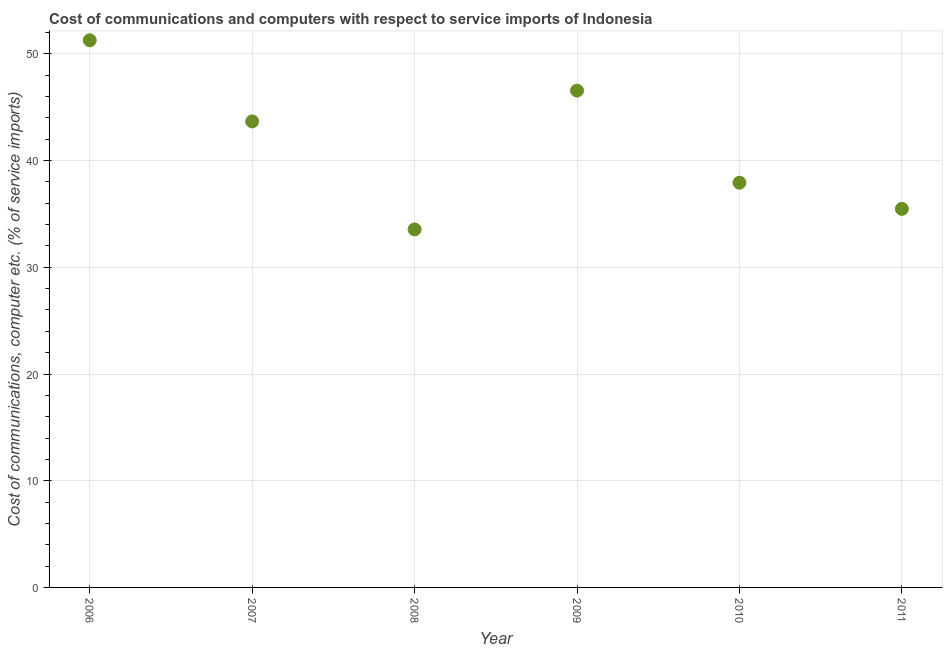What is the cost of communications and computer in 2008?
Provide a short and direct response. 33.55. Across all years, what is the maximum cost of communications and computer?
Offer a very short reply. 51.27. Across all years, what is the minimum cost of communications and computer?
Ensure brevity in your answer.  33.55. In which year was the cost of communications and computer minimum?
Give a very brief answer. 2008. What is the sum of the cost of communications and computer?
Your answer should be very brief. 248.46. What is the difference between the cost of communications and computer in 2006 and 2010?
Provide a succinct answer. 13.35. What is the average cost of communications and computer per year?
Make the answer very short. 41.41. What is the median cost of communications and computer?
Keep it short and to the point. 40.8. Do a majority of the years between 2007 and 2010 (inclusive) have cost of communications and computer greater than 20 %?
Provide a succinct answer. Yes. What is the ratio of the cost of communications and computer in 2006 to that in 2009?
Provide a short and direct response. 1.1. What is the difference between the highest and the second highest cost of communications and computer?
Your response must be concise. 4.71. What is the difference between the highest and the lowest cost of communications and computer?
Keep it short and to the point. 17.72. In how many years, is the cost of communications and computer greater than the average cost of communications and computer taken over all years?
Offer a terse response. 3. What is the title of the graph?
Ensure brevity in your answer.  Cost of communications and computers with respect to service imports of Indonesia. What is the label or title of the Y-axis?
Your response must be concise. Cost of communications, computer etc. (% of service imports). What is the Cost of communications, computer etc. (% of service imports) in 2006?
Offer a terse response. 51.27. What is the Cost of communications, computer etc. (% of service imports) in 2007?
Offer a terse response. 43.67. What is the Cost of communications, computer etc. (% of service imports) in 2008?
Offer a terse response. 33.55. What is the Cost of communications, computer etc. (% of service imports) in 2009?
Make the answer very short. 46.56. What is the Cost of communications, computer etc. (% of service imports) in 2010?
Ensure brevity in your answer.  37.93. What is the Cost of communications, computer etc. (% of service imports) in 2011?
Your answer should be very brief. 35.48. What is the difference between the Cost of communications, computer etc. (% of service imports) in 2006 and 2007?
Keep it short and to the point. 7.6. What is the difference between the Cost of communications, computer etc. (% of service imports) in 2006 and 2008?
Your response must be concise. 17.72. What is the difference between the Cost of communications, computer etc. (% of service imports) in 2006 and 2009?
Keep it short and to the point. 4.71. What is the difference between the Cost of communications, computer etc. (% of service imports) in 2006 and 2010?
Keep it short and to the point. 13.35. What is the difference between the Cost of communications, computer etc. (% of service imports) in 2006 and 2011?
Give a very brief answer. 15.8. What is the difference between the Cost of communications, computer etc. (% of service imports) in 2007 and 2008?
Your answer should be very brief. 10.12. What is the difference between the Cost of communications, computer etc. (% of service imports) in 2007 and 2009?
Ensure brevity in your answer.  -2.89. What is the difference between the Cost of communications, computer etc. (% of service imports) in 2007 and 2010?
Ensure brevity in your answer.  5.75. What is the difference between the Cost of communications, computer etc. (% of service imports) in 2007 and 2011?
Make the answer very short. 8.2. What is the difference between the Cost of communications, computer etc. (% of service imports) in 2008 and 2009?
Offer a very short reply. -13.01. What is the difference between the Cost of communications, computer etc. (% of service imports) in 2008 and 2010?
Give a very brief answer. -4.38. What is the difference between the Cost of communications, computer etc. (% of service imports) in 2008 and 2011?
Your response must be concise. -1.92. What is the difference between the Cost of communications, computer etc. (% of service imports) in 2009 and 2010?
Provide a short and direct response. 8.63. What is the difference between the Cost of communications, computer etc. (% of service imports) in 2009 and 2011?
Ensure brevity in your answer.  11.09. What is the difference between the Cost of communications, computer etc. (% of service imports) in 2010 and 2011?
Your answer should be compact. 2.45. What is the ratio of the Cost of communications, computer etc. (% of service imports) in 2006 to that in 2007?
Provide a succinct answer. 1.17. What is the ratio of the Cost of communications, computer etc. (% of service imports) in 2006 to that in 2008?
Offer a terse response. 1.53. What is the ratio of the Cost of communications, computer etc. (% of service imports) in 2006 to that in 2009?
Keep it short and to the point. 1.1. What is the ratio of the Cost of communications, computer etc. (% of service imports) in 2006 to that in 2010?
Provide a short and direct response. 1.35. What is the ratio of the Cost of communications, computer etc. (% of service imports) in 2006 to that in 2011?
Offer a terse response. 1.45. What is the ratio of the Cost of communications, computer etc. (% of service imports) in 2007 to that in 2008?
Offer a terse response. 1.3. What is the ratio of the Cost of communications, computer etc. (% of service imports) in 2007 to that in 2009?
Keep it short and to the point. 0.94. What is the ratio of the Cost of communications, computer etc. (% of service imports) in 2007 to that in 2010?
Offer a terse response. 1.15. What is the ratio of the Cost of communications, computer etc. (% of service imports) in 2007 to that in 2011?
Ensure brevity in your answer.  1.23. What is the ratio of the Cost of communications, computer etc. (% of service imports) in 2008 to that in 2009?
Keep it short and to the point. 0.72. What is the ratio of the Cost of communications, computer etc. (% of service imports) in 2008 to that in 2010?
Provide a short and direct response. 0.89. What is the ratio of the Cost of communications, computer etc. (% of service imports) in 2008 to that in 2011?
Your answer should be very brief. 0.95. What is the ratio of the Cost of communications, computer etc. (% of service imports) in 2009 to that in 2010?
Provide a short and direct response. 1.23. What is the ratio of the Cost of communications, computer etc. (% of service imports) in 2009 to that in 2011?
Your answer should be compact. 1.31. What is the ratio of the Cost of communications, computer etc. (% of service imports) in 2010 to that in 2011?
Your response must be concise. 1.07. 